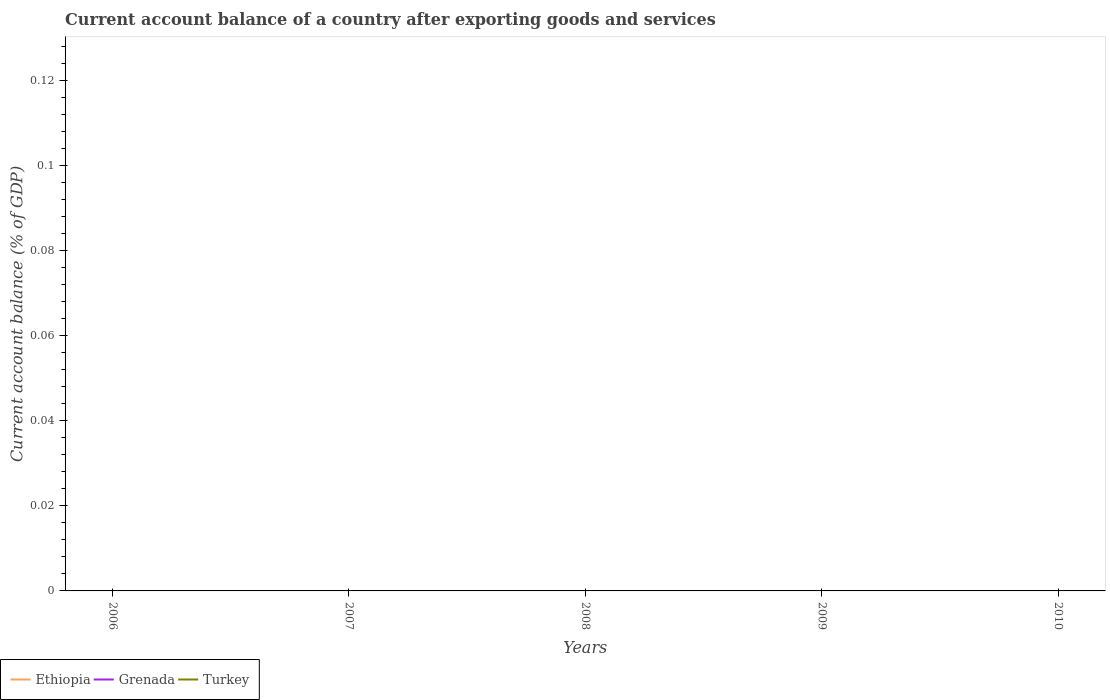How many different coloured lines are there?
Offer a terse response. 0. Does the line corresponding to Ethiopia intersect with the line corresponding to Turkey?
Offer a very short reply. Yes. Is the number of lines equal to the number of legend labels?
Your answer should be compact. No. What is the difference between the highest and the lowest account balance in Ethiopia?
Offer a very short reply. 0. Is the account balance in Grenada strictly greater than the account balance in Ethiopia over the years?
Your response must be concise. Yes. How many years are there in the graph?
Give a very brief answer. 5. What is the difference between two consecutive major ticks on the Y-axis?
Give a very brief answer. 0.02. Are the values on the major ticks of Y-axis written in scientific E-notation?
Offer a very short reply. No. Does the graph contain grids?
Keep it short and to the point. No. Where does the legend appear in the graph?
Your answer should be compact. Bottom left. What is the title of the graph?
Offer a terse response. Current account balance of a country after exporting goods and services. What is the label or title of the Y-axis?
Your response must be concise. Current account balance (% of GDP). What is the Current account balance (% of GDP) of Ethiopia in 2006?
Your response must be concise. 0. What is the Current account balance (% of GDP) in Grenada in 2006?
Offer a very short reply. 0. What is the Current account balance (% of GDP) of Turkey in 2006?
Ensure brevity in your answer.  0. What is the Current account balance (% of GDP) in Grenada in 2007?
Offer a very short reply. 0. What is the Current account balance (% of GDP) of Turkey in 2007?
Keep it short and to the point. 0. What is the Current account balance (% of GDP) in Turkey in 2009?
Offer a terse response. 0. What is the Current account balance (% of GDP) of Grenada in 2010?
Your response must be concise. 0. What is the total Current account balance (% of GDP) of Ethiopia in the graph?
Provide a succinct answer. 0. What is the total Current account balance (% of GDP) of Grenada in the graph?
Keep it short and to the point. 0. What is the total Current account balance (% of GDP) of Turkey in the graph?
Provide a short and direct response. 0. What is the average Current account balance (% of GDP) in Ethiopia per year?
Your answer should be compact. 0. What is the average Current account balance (% of GDP) of Turkey per year?
Offer a terse response. 0. 